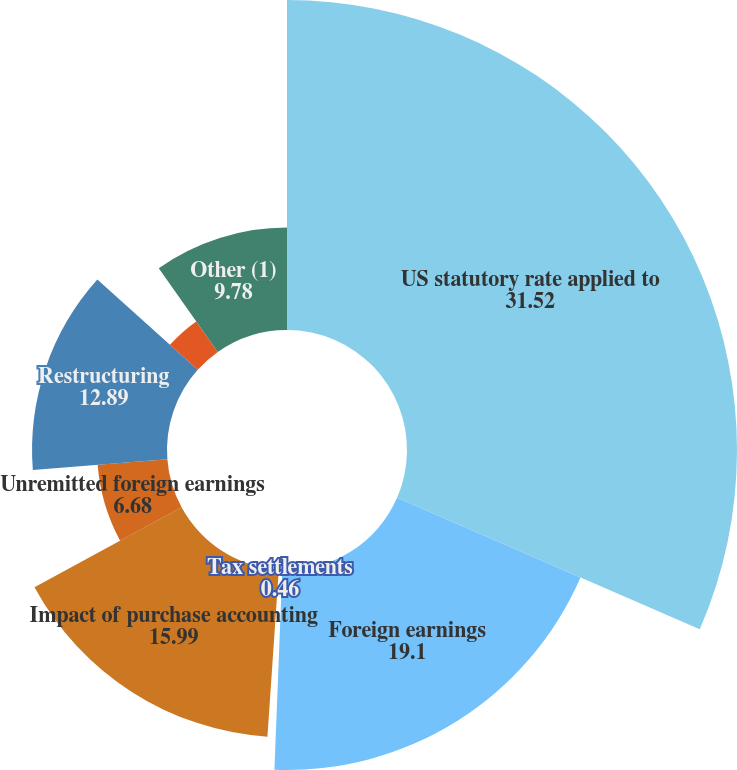<chart> <loc_0><loc_0><loc_500><loc_500><pie_chart><fcel>US statutory rate applied to<fcel>Foreign earnings<fcel>Tax settlements<fcel>Impact of purchase accounting<fcel>Unremitted foreign earnings<fcel>Restructuring<fcel>US health care reform<fcel>Other (1)<nl><fcel>31.52%<fcel>19.1%<fcel>0.46%<fcel>15.99%<fcel>6.68%<fcel>12.89%<fcel>3.57%<fcel>9.78%<nl></chart> 